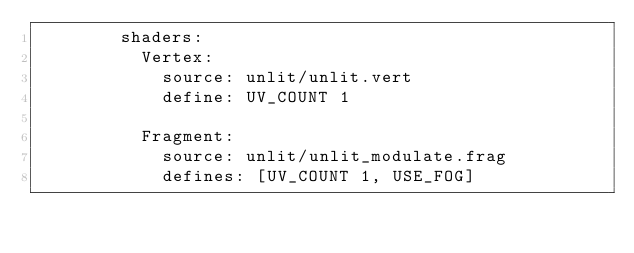<code> <loc_0><loc_0><loc_500><loc_500><_YAML_>        shaders: 
          Vertex: 
            source: unlit/unlit.vert
            define: UV_COUNT 1
                        
          Fragment:
            source: unlit/unlit_modulate.frag
            defines: [UV_COUNT 1, USE_FOG]</code> 